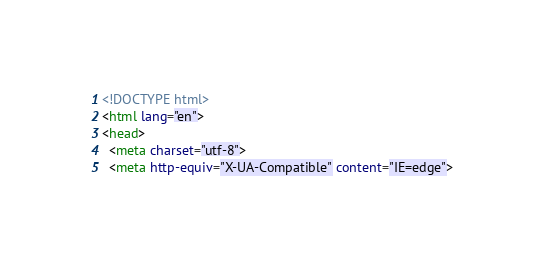<code> <loc_0><loc_0><loc_500><loc_500><_HTML_><!DOCTYPE html>
<html lang="en">
<head>
  <meta charset="utf-8">
  <meta http-equiv="X-UA-Compatible" content="IE=edge"></code> 